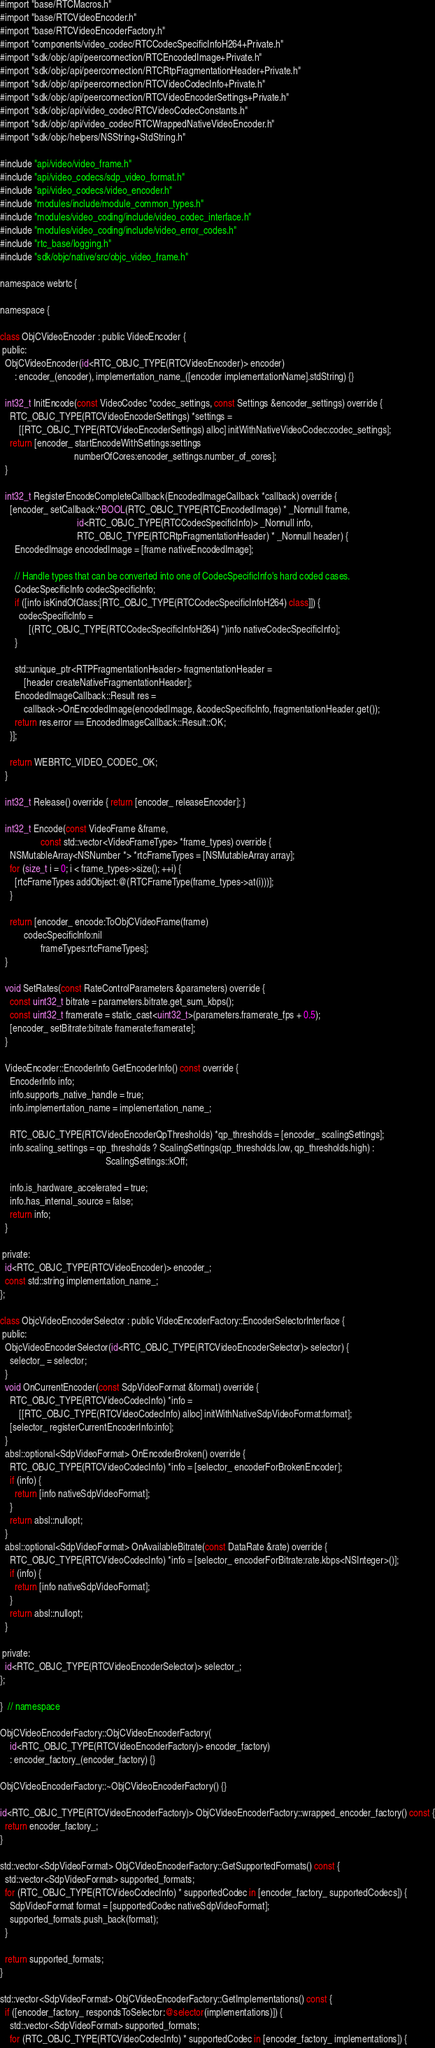Convert code to text. <code><loc_0><loc_0><loc_500><loc_500><_ObjectiveC_>#import "base/RTCMacros.h"
#import "base/RTCVideoEncoder.h"
#import "base/RTCVideoEncoderFactory.h"
#import "components/video_codec/RTCCodecSpecificInfoH264+Private.h"
#import "sdk/objc/api/peerconnection/RTCEncodedImage+Private.h"
#import "sdk/objc/api/peerconnection/RTCRtpFragmentationHeader+Private.h"
#import "sdk/objc/api/peerconnection/RTCVideoCodecInfo+Private.h"
#import "sdk/objc/api/peerconnection/RTCVideoEncoderSettings+Private.h"
#import "sdk/objc/api/video_codec/RTCVideoCodecConstants.h"
#import "sdk/objc/api/video_codec/RTCWrappedNativeVideoEncoder.h"
#import "sdk/objc/helpers/NSString+StdString.h"

#include "api/video/video_frame.h"
#include "api/video_codecs/sdp_video_format.h"
#include "api/video_codecs/video_encoder.h"
#include "modules/include/module_common_types.h"
#include "modules/video_coding/include/video_codec_interface.h"
#include "modules/video_coding/include/video_error_codes.h"
#include "rtc_base/logging.h"
#include "sdk/objc/native/src/objc_video_frame.h"

namespace webrtc {

namespace {

class ObjCVideoEncoder : public VideoEncoder {
 public:
  ObjCVideoEncoder(id<RTC_OBJC_TYPE(RTCVideoEncoder)> encoder)
      : encoder_(encoder), implementation_name_([encoder implementationName].stdString) {}

  int32_t InitEncode(const VideoCodec *codec_settings, const Settings &encoder_settings) override {
    RTC_OBJC_TYPE(RTCVideoEncoderSettings) *settings =
        [[RTC_OBJC_TYPE(RTCVideoEncoderSettings) alloc] initWithNativeVideoCodec:codec_settings];
    return [encoder_ startEncodeWithSettings:settings
                               numberOfCores:encoder_settings.number_of_cores];
  }

  int32_t RegisterEncodeCompleteCallback(EncodedImageCallback *callback) override {
    [encoder_ setCallback:^BOOL(RTC_OBJC_TYPE(RTCEncodedImage) * _Nonnull frame,
                                id<RTC_OBJC_TYPE(RTCCodecSpecificInfo)> _Nonnull info,
                                RTC_OBJC_TYPE(RTCRtpFragmentationHeader) * _Nonnull header) {
      EncodedImage encodedImage = [frame nativeEncodedImage];

      // Handle types that can be converted into one of CodecSpecificInfo's hard coded cases.
      CodecSpecificInfo codecSpecificInfo;
      if ([info isKindOfClass:[RTC_OBJC_TYPE(RTCCodecSpecificInfoH264) class]]) {
        codecSpecificInfo =
            [(RTC_OBJC_TYPE(RTCCodecSpecificInfoH264) *)info nativeCodecSpecificInfo];
      }

      std::unique_ptr<RTPFragmentationHeader> fragmentationHeader =
          [header createNativeFragmentationHeader];
      EncodedImageCallback::Result res =
          callback->OnEncodedImage(encodedImage, &codecSpecificInfo, fragmentationHeader.get());
      return res.error == EncodedImageCallback::Result::OK;
    }];

    return WEBRTC_VIDEO_CODEC_OK;
  }

  int32_t Release() override { return [encoder_ releaseEncoder]; }

  int32_t Encode(const VideoFrame &frame,
                 const std::vector<VideoFrameType> *frame_types) override {
    NSMutableArray<NSNumber *> *rtcFrameTypes = [NSMutableArray array];
    for (size_t i = 0; i < frame_types->size(); ++i) {
      [rtcFrameTypes addObject:@(RTCFrameType(frame_types->at(i)))];
    }

    return [encoder_ encode:ToObjCVideoFrame(frame)
          codecSpecificInfo:nil
                 frameTypes:rtcFrameTypes];
  }

  void SetRates(const RateControlParameters &parameters) override {
    const uint32_t bitrate = parameters.bitrate.get_sum_kbps();
    const uint32_t framerate = static_cast<uint32_t>(parameters.framerate_fps + 0.5);
    [encoder_ setBitrate:bitrate framerate:framerate];
  }

  VideoEncoder::EncoderInfo GetEncoderInfo() const override {
    EncoderInfo info;
    info.supports_native_handle = true;
    info.implementation_name = implementation_name_;

    RTC_OBJC_TYPE(RTCVideoEncoderQpThresholds) *qp_thresholds = [encoder_ scalingSettings];
    info.scaling_settings = qp_thresholds ? ScalingSettings(qp_thresholds.low, qp_thresholds.high) :
                                            ScalingSettings::kOff;

    info.is_hardware_accelerated = true;
    info.has_internal_source = false;
    return info;
  }

 private:
  id<RTC_OBJC_TYPE(RTCVideoEncoder)> encoder_;
  const std::string implementation_name_;
};

class ObjcVideoEncoderSelector : public VideoEncoderFactory::EncoderSelectorInterface {
 public:
  ObjcVideoEncoderSelector(id<RTC_OBJC_TYPE(RTCVideoEncoderSelector)> selector) {
    selector_ = selector;
  }
  void OnCurrentEncoder(const SdpVideoFormat &format) override {
    RTC_OBJC_TYPE(RTCVideoCodecInfo) *info =
        [[RTC_OBJC_TYPE(RTCVideoCodecInfo) alloc] initWithNativeSdpVideoFormat:format];
    [selector_ registerCurrentEncoderInfo:info];
  }
  absl::optional<SdpVideoFormat> OnEncoderBroken() override {
    RTC_OBJC_TYPE(RTCVideoCodecInfo) *info = [selector_ encoderForBrokenEncoder];
    if (info) {
      return [info nativeSdpVideoFormat];
    }
    return absl::nullopt;
  }
  absl::optional<SdpVideoFormat> OnAvailableBitrate(const DataRate &rate) override {
    RTC_OBJC_TYPE(RTCVideoCodecInfo) *info = [selector_ encoderForBitrate:rate.kbps<NSInteger>()];
    if (info) {
      return [info nativeSdpVideoFormat];
    }
    return absl::nullopt;
  }

 private:
  id<RTC_OBJC_TYPE(RTCVideoEncoderSelector)> selector_;
};

}  // namespace

ObjCVideoEncoderFactory::ObjCVideoEncoderFactory(
    id<RTC_OBJC_TYPE(RTCVideoEncoderFactory)> encoder_factory)
    : encoder_factory_(encoder_factory) {}

ObjCVideoEncoderFactory::~ObjCVideoEncoderFactory() {}

id<RTC_OBJC_TYPE(RTCVideoEncoderFactory)> ObjCVideoEncoderFactory::wrapped_encoder_factory() const {
  return encoder_factory_;
}

std::vector<SdpVideoFormat> ObjCVideoEncoderFactory::GetSupportedFormats() const {
  std::vector<SdpVideoFormat> supported_formats;
  for (RTC_OBJC_TYPE(RTCVideoCodecInfo) * supportedCodec in [encoder_factory_ supportedCodecs]) {
    SdpVideoFormat format = [supportedCodec nativeSdpVideoFormat];
    supported_formats.push_back(format);
  }

  return supported_formats;
}

std::vector<SdpVideoFormat> ObjCVideoEncoderFactory::GetImplementations() const {
  if ([encoder_factory_ respondsToSelector:@selector(implementations)]) {
    std::vector<SdpVideoFormat> supported_formats;
    for (RTC_OBJC_TYPE(RTCVideoCodecInfo) * supportedCodec in [encoder_factory_ implementations]) {</code> 